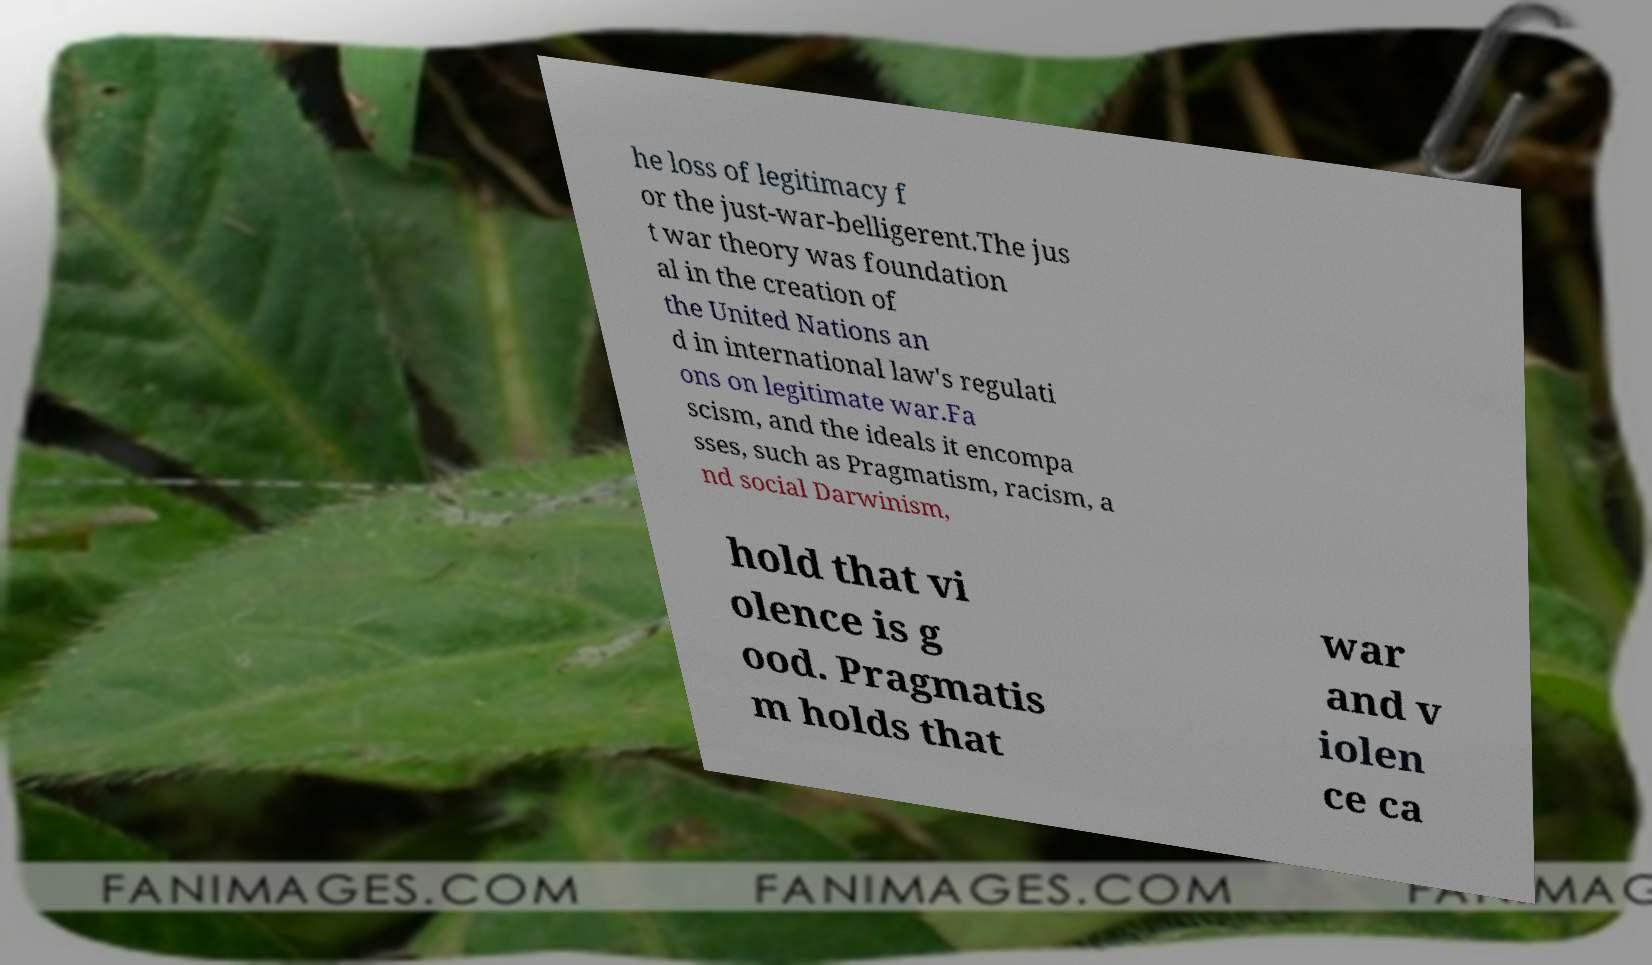For documentation purposes, I need the text within this image transcribed. Could you provide that? he loss of legitimacy f or the just-war-belligerent.The jus t war theory was foundation al in the creation of the United Nations an d in international law's regulati ons on legitimate war.Fa scism, and the ideals it encompa sses, such as Pragmatism, racism, a nd social Darwinism, hold that vi olence is g ood. Pragmatis m holds that war and v iolen ce ca 